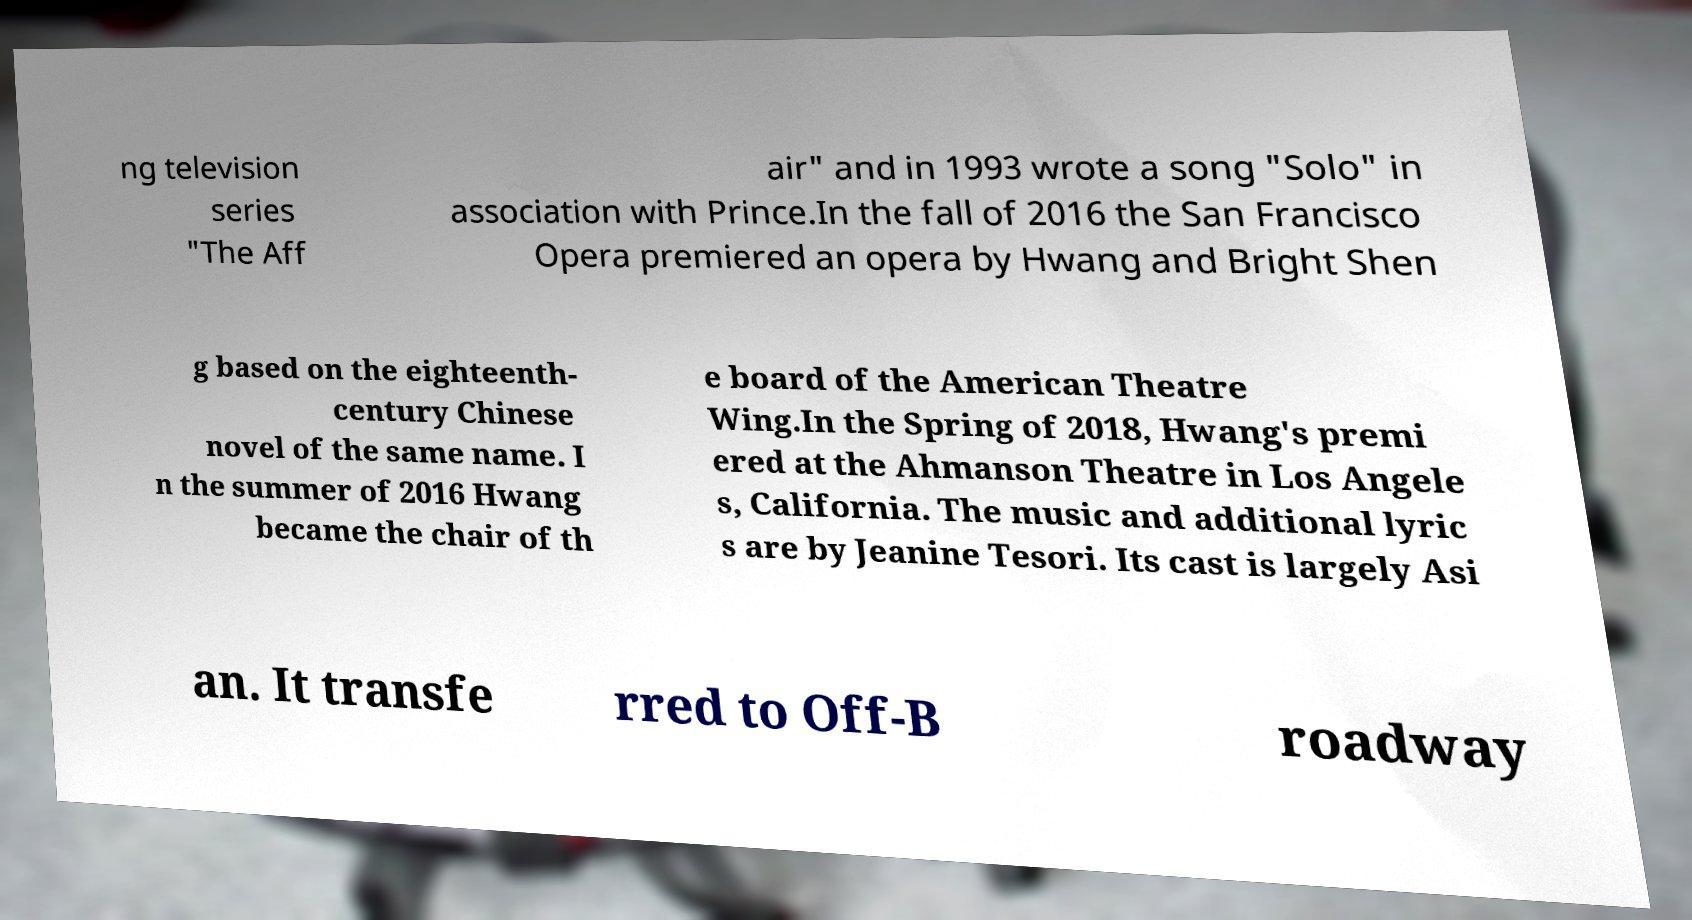Please read and relay the text visible in this image. What does it say? ng television series "The Aff air" and in 1993 wrote a song "Solo" in association with Prince.In the fall of 2016 the San Francisco Opera premiered an opera by Hwang and Bright Shen g based on the eighteenth- century Chinese novel of the same name. I n the summer of 2016 Hwang became the chair of th e board of the American Theatre Wing.In the Spring of 2018, Hwang's premi ered at the Ahmanson Theatre in Los Angele s, California. The music and additional lyric s are by Jeanine Tesori. Its cast is largely Asi an. It transfe rred to Off-B roadway 